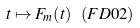<formula> <loc_0><loc_0><loc_500><loc_500>t \mapsto F _ { m } ( t ) \ ( F D 0 2 )</formula> 